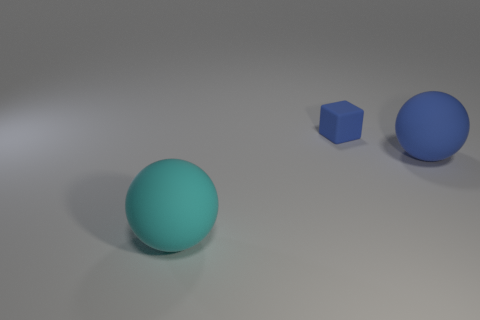What number of other objects are the same size as the rubber cube?
Your answer should be compact. 0. How many big things are the same color as the small matte thing?
Your answer should be compact. 1. Are there any other spheres that have the same size as the cyan matte ball?
Offer a very short reply. Yes. What is the material of the cyan thing that is the same size as the blue ball?
Your answer should be compact. Rubber. What is the size of the matte sphere to the left of the big thing that is right of the cyan matte object?
Keep it short and to the point. Large. There is a matte object that is to the left of the block; is it the same size as the tiny cube?
Offer a very short reply. No. Are there more large spheres that are to the left of the tiny blue matte block than matte balls in front of the big cyan sphere?
Offer a very short reply. Yes. What shape is the matte object that is to the left of the blue rubber ball and in front of the cube?
Provide a succinct answer. Sphere. What is the shape of the small matte thing behind the large blue matte thing?
Ensure brevity in your answer.  Cube. What size is the blue matte block that is right of the big ball left of the sphere behind the large cyan ball?
Your response must be concise. Small. 